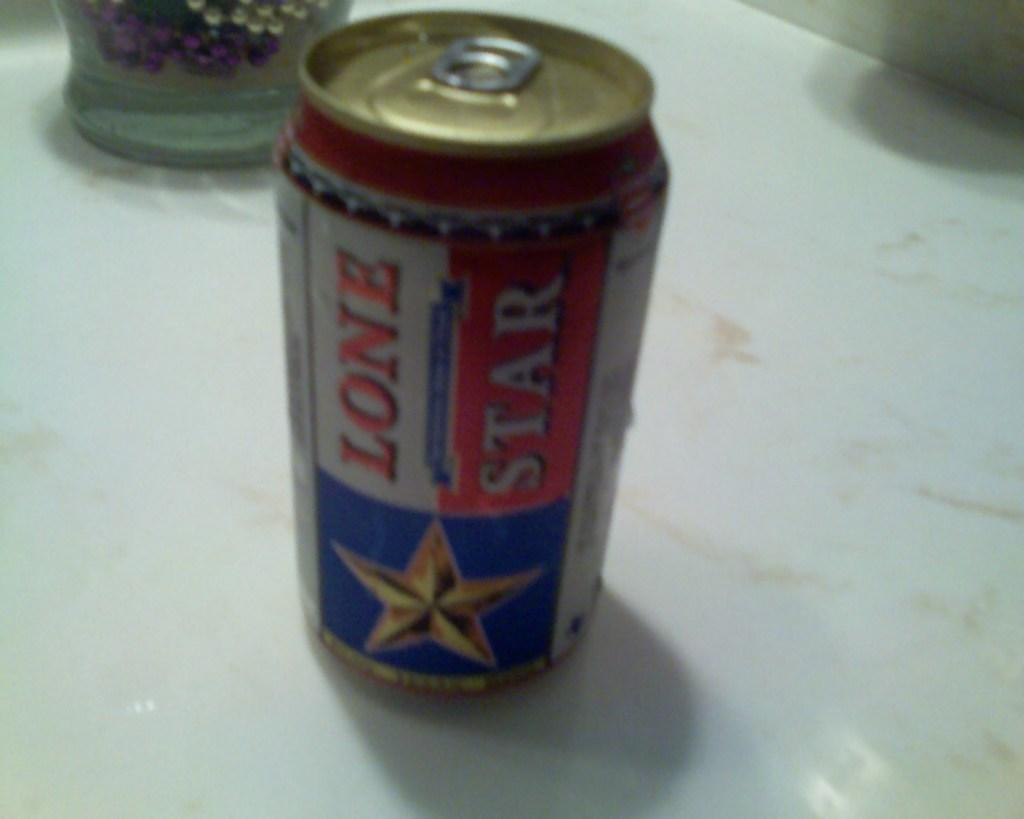<image>
Relay a brief, clear account of the picture shown. A red, white, and blue can of Lone Star beer sits on a counter. 